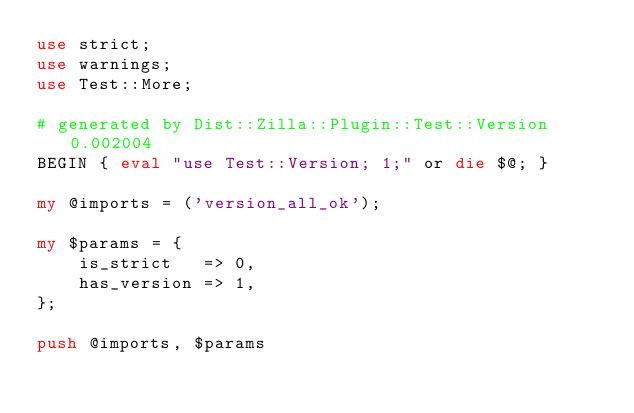Convert code to text. <code><loc_0><loc_0><loc_500><loc_500><_Perl_>use strict;
use warnings;
use Test::More;

# generated by Dist::Zilla::Plugin::Test::Version 0.002004
BEGIN { eval "use Test::Version; 1;" or die $@; }

my @imports = ('version_all_ok');

my $params = {
    is_strict   => 0,
    has_version => 1,
};

push @imports, $params</code> 